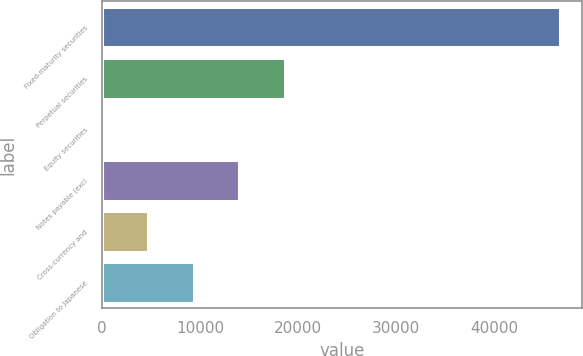<chart> <loc_0><loc_0><loc_500><loc_500><bar_chart><fcel>Fixed-maturity securities<fcel>Perpetual securities<fcel>Equity securities<fcel>Notes payable (excl<fcel>Cross-currency and<fcel>Obligation to Japanese<nl><fcel>46702<fcel>18697.6<fcel>28<fcel>14030.2<fcel>4695.4<fcel>9362.8<nl></chart> 